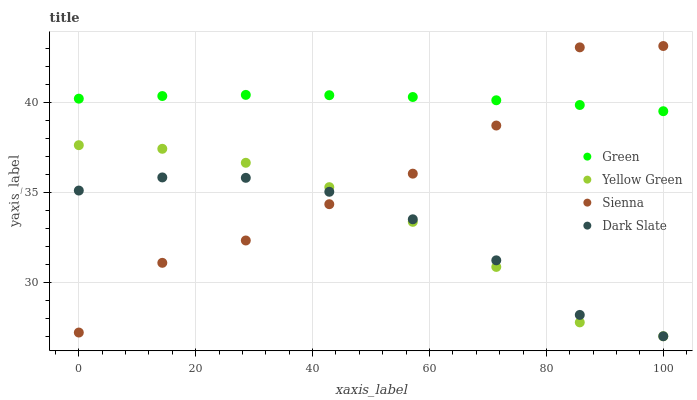Does Dark Slate have the minimum area under the curve?
Answer yes or no. Yes. Does Green have the maximum area under the curve?
Answer yes or no. Yes. Does Green have the minimum area under the curve?
Answer yes or no. No. Does Dark Slate have the maximum area under the curve?
Answer yes or no. No. Is Green the smoothest?
Answer yes or no. Yes. Is Sienna the roughest?
Answer yes or no. Yes. Is Dark Slate the smoothest?
Answer yes or no. No. Is Dark Slate the roughest?
Answer yes or no. No. Does Dark Slate have the lowest value?
Answer yes or no. Yes. Does Green have the lowest value?
Answer yes or no. No. Does Sienna have the highest value?
Answer yes or no. Yes. Does Green have the highest value?
Answer yes or no. No. Is Dark Slate less than Green?
Answer yes or no. Yes. Is Green greater than Yellow Green?
Answer yes or no. Yes. Does Sienna intersect Dark Slate?
Answer yes or no. Yes. Is Sienna less than Dark Slate?
Answer yes or no. No. Is Sienna greater than Dark Slate?
Answer yes or no. No. Does Dark Slate intersect Green?
Answer yes or no. No. 